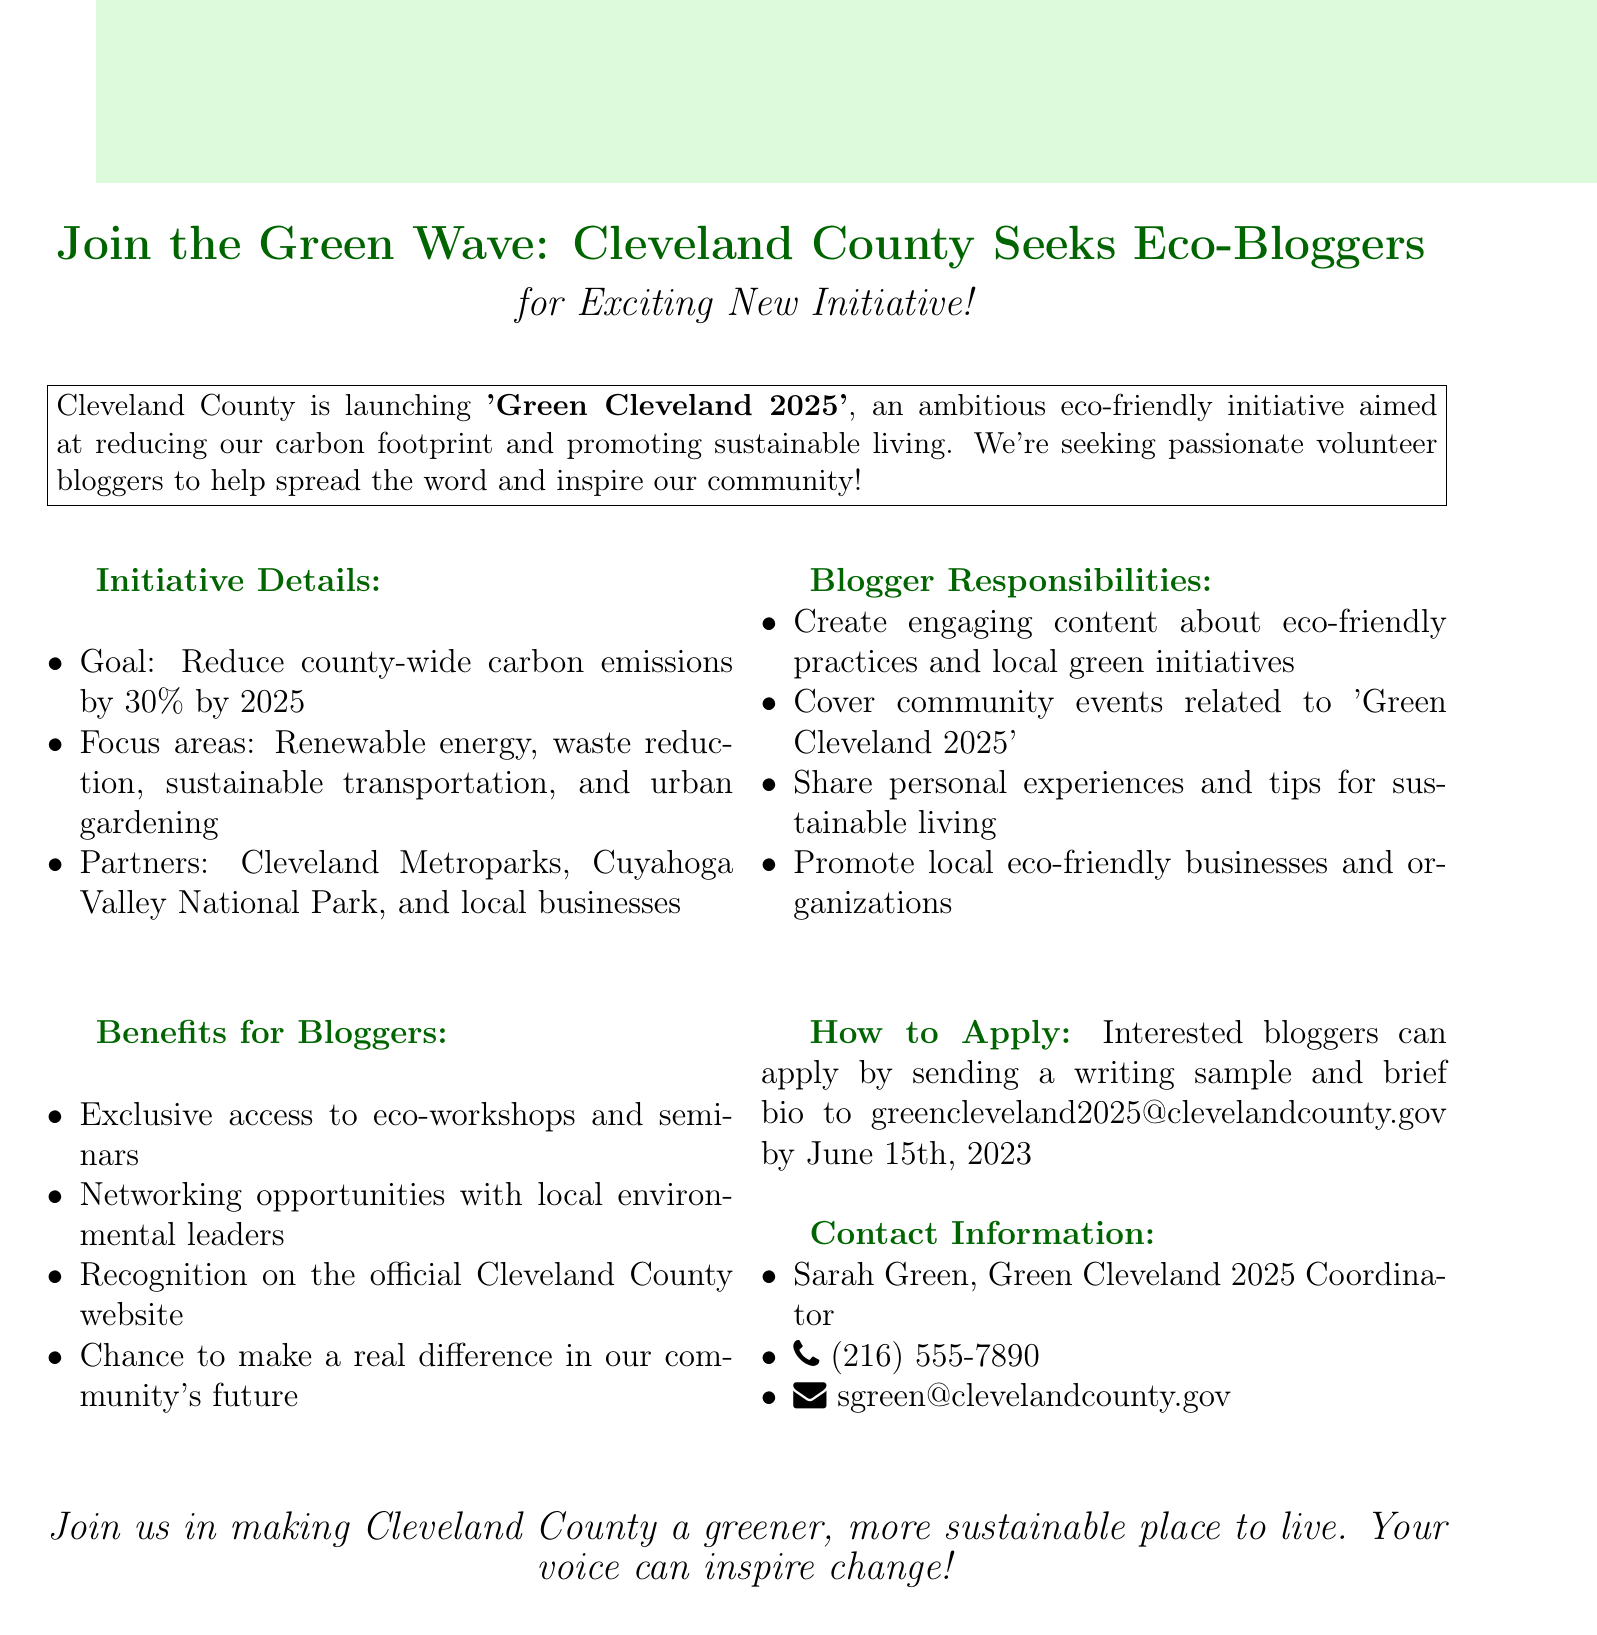What is the goal of the initiative? The goal is to reduce county-wide carbon emissions by 30% by 2025.
Answer: Reduce county-wide carbon emissions by 30% by 2025 Who is the contact person for this initiative? The contact person is mentioned in the document under contact information, providing name and title.
Answer: Sarah Green When is the application deadline for bloggers? The application deadline is specified in the 'How to Apply' section of the document.
Answer: June 15th, 2023 What type of content should bloggers create? This requires referencing the responsibilities specified for the bloggers in the document.
Answer: Engaging content about eco-friendly practices What are the partners involved in this initiative? Partners are listed in the document, outlining those collaborating on the initiative.
Answer: Cleveland Metroparks, Cuyahoga Valley National Park, and local businesses What is one benefit mentioned for bloggers? The benefits for bloggers are outlined in the respective section, highlighting what they would gain.
Answer: Exclusive access to eco-workshops and seminars How can interested bloggers apply? The document provides instructions on how to apply, indicating the required submission.
Answer: By sending a writing sample and brief bio Which areas does the initiative focus on? The focus areas are listed in the 'Initiative Details' section of the document.
Answer: Renewable energy, waste reduction, sustainable transportation, and urban gardening 